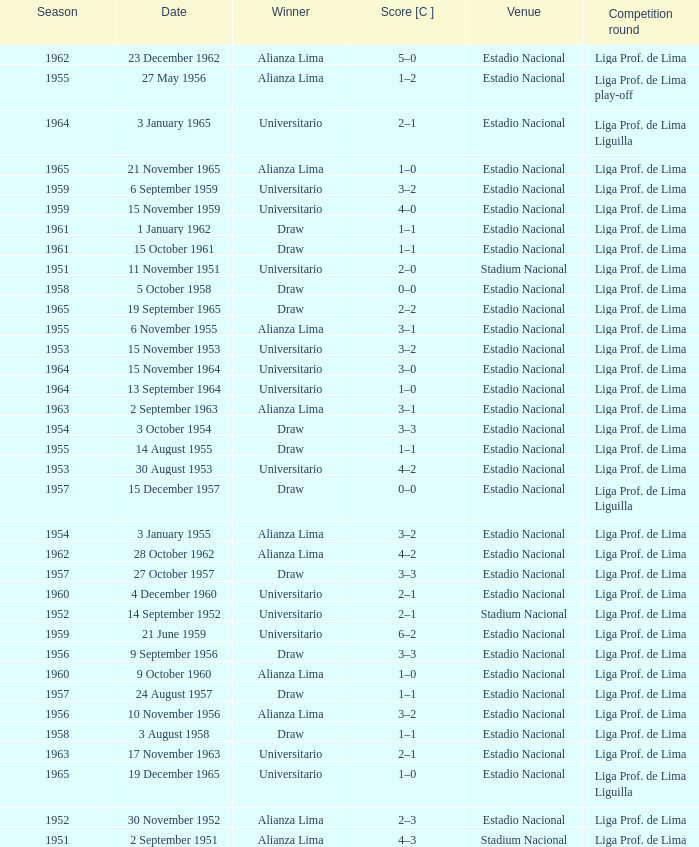What is the most recent season with a date of 27 October 1957? 1957.0. 